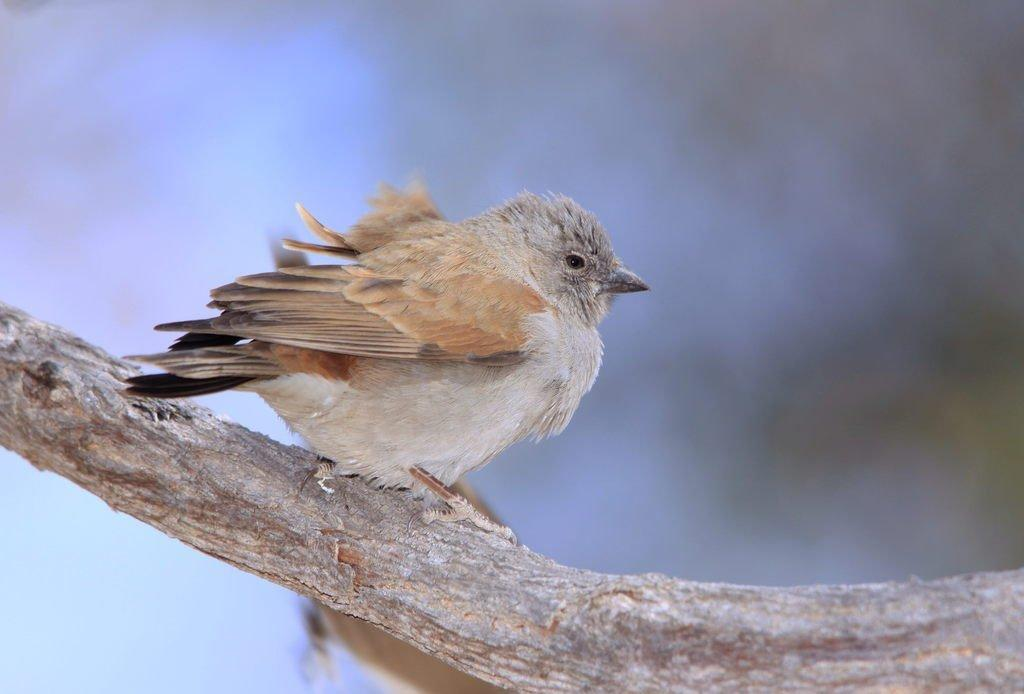What is the main subject of the image? The main subject of the image is a tree stem. Is there any other living organism present in the image? Yes, there is a bird on the tree stem. What type of advice can be seen written on the lace in the image? There is no lace or any written advice present in the image. What type of dishware is visible in the image? There is no dishware, such as a plate, present in the image. 